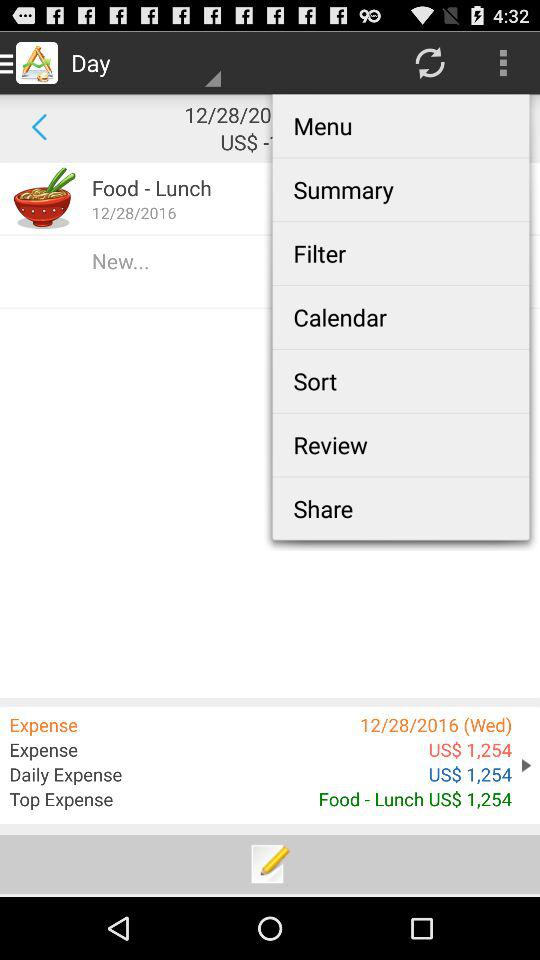What is the daily expense? The daily expense is $1,254. 